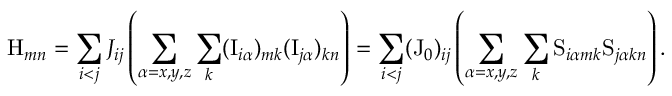<formula> <loc_0><loc_0><loc_500><loc_500>H _ { m n } = \sum _ { i < j } J _ { i j } \left ( \sum _ { \alpha = x , y , z } \sum _ { k } ( I _ { i \alpha } ) _ { m k } ( I _ { j \alpha } ) _ { k n } \right ) = \sum _ { i < j } ( J _ { 0 } ) _ { i j } \left ( \sum _ { \alpha = x , y , z } \sum _ { k } S _ { i \alpha m k } S _ { j \alpha k n } \right ) .</formula> 